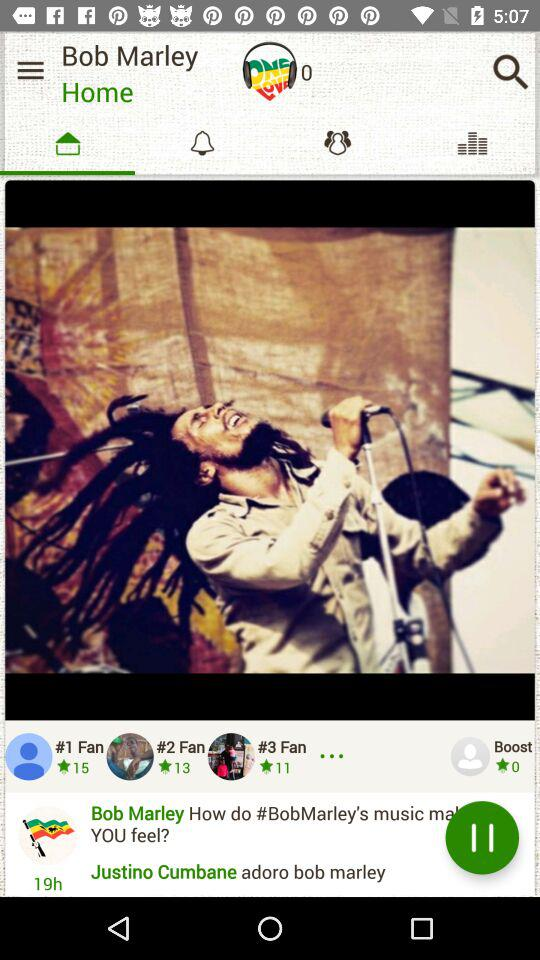How many fans are there?
Answer the question using a single word or phrase. 3 